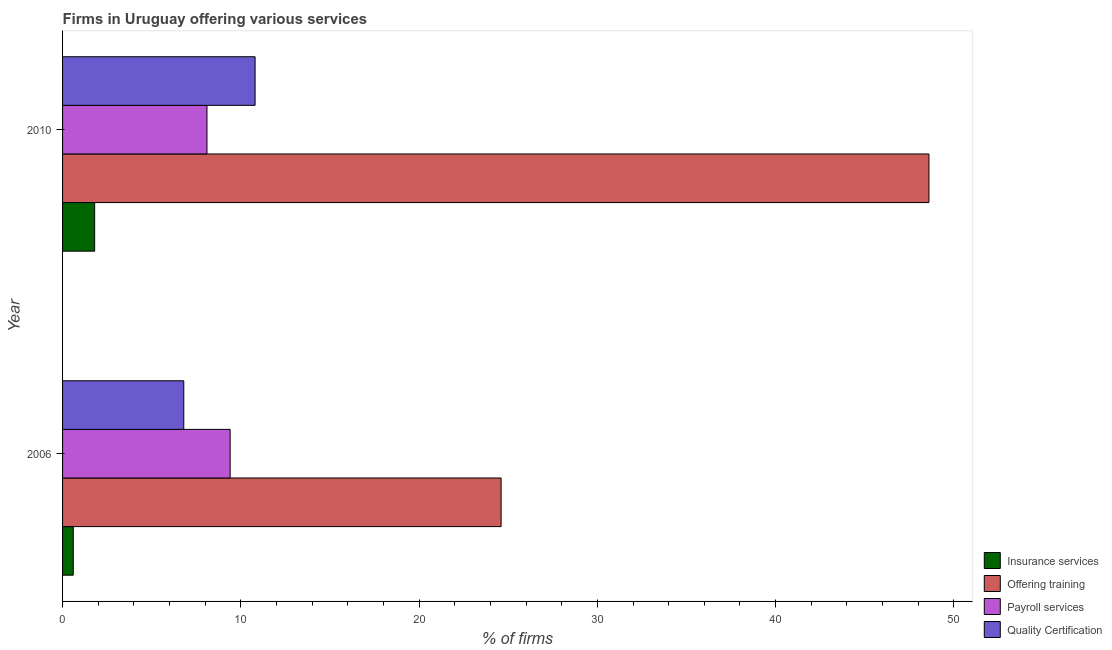How many groups of bars are there?
Make the answer very short. 2. Are the number of bars per tick equal to the number of legend labels?
Provide a succinct answer. Yes. Are the number of bars on each tick of the Y-axis equal?
Your answer should be very brief. Yes. How many bars are there on the 2nd tick from the bottom?
Your answer should be very brief. 4. What is the label of the 1st group of bars from the top?
Give a very brief answer. 2010. What is the percentage of firms offering insurance services in 2010?
Your response must be concise. 1.8. Across all years, what is the minimum percentage of firms offering training?
Ensure brevity in your answer.  24.6. What is the difference between the percentage of firms offering training in 2006 and that in 2010?
Your answer should be very brief. -24. What is the difference between the percentage of firms offering payroll services in 2010 and the percentage of firms offering quality certification in 2006?
Offer a terse response. 1.3. What is the average percentage of firms offering training per year?
Provide a succinct answer. 36.6. In the year 2006, what is the difference between the percentage of firms offering payroll services and percentage of firms offering training?
Give a very brief answer. -15.2. In how many years, is the percentage of firms offering insurance services greater than 18 %?
Your answer should be compact. 0. What is the ratio of the percentage of firms offering quality certification in 2006 to that in 2010?
Your response must be concise. 0.63. Is the percentage of firms offering payroll services in 2006 less than that in 2010?
Offer a very short reply. No. What does the 2nd bar from the top in 2006 represents?
Give a very brief answer. Payroll services. What does the 2nd bar from the bottom in 2010 represents?
Provide a succinct answer. Offering training. Is it the case that in every year, the sum of the percentage of firms offering insurance services and percentage of firms offering training is greater than the percentage of firms offering payroll services?
Offer a terse response. Yes. How many bars are there?
Provide a short and direct response. 8. Are all the bars in the graph horizontal?
Your response must be concise. Yes. What is the difference between two consecutive major ticks on the X-axis?
Your response must be concise. 10. Does the graph contain any zero values?
Make the answer very short. No. Where does the legend appear in the graph?
Give a very brief answer. Bottom right. What is the title of the graph?
Keep it short and to the point. Firms in Uruguay offering various services . What is the label or title of the X-axis?
Offer a very short reply. % of firms. What is the label or title of the Y-axis?
Offer a very short reply. Year. What is the % of firms of Insurance services in 2006?
Your answer should be compact. 0.6. What is the % of firms in Offering training in 2006?
Give a very brief answer. 24.6. What is the % of firms in Payroll services in 2006?
Your answer should be very brief. 9.4. What is the % of firms of Quality Certification in 2006?
Ensure brevity in your answer.  6.8. What is the % of firms of Insurance services in 2010?
Offer a very short reply. 1.8. What is the % of firms of Offering training in 2010?
Offer a very short reply. 48.6. What is the % of firms in Payroll services in 2010?
Provide a succinct answer. 8.1. Across all years, what is the maximum % of firms in Offering training?
Give a very brief answer. 48.6. Across all years, what is the minimum % of firms of Offering training?
Offer a very short reply. 24.6. Across all years, what is the minimum % of firms in Payroll services?
Your answer should be compact. 8.1. What is the total % of firms of Insurance services in the graph?
Your answer should be very brief. 2.4. What is the total % of firms in Offering training in the graph?
Your response must be concise. 73.2. What is the total % of firms in Payroll services in the graph?
Your answer should be very brief. 17.5. What is the difference between the % of firms of Insurance services in 2006 and the % of firms of Offering training in 2010?
Give a very brief answer. -48. What is the difference between the % of firms of Insurance services in 2006 and the % of firms of Quality Certification in 2010?
Keep it short and to the point. -10.2. What is the difference between the % of firms in Offering training in 2006 and the % of firms in Payroll services in 2010?
Your answer should be very brief. 16.5. What is the average % of firms of Offering training per year?
Make the answer very short. 36.6. What is the average % of firms of Payroll services per year?
Provide a short and direct response. 8.75. In the year 2006, what is the difference between the % of firms of Offering training and % of firms of Payroll services?
Ensure brevity in your answer.  15.2. In the year 2010, what is the difference between the % of firms in Insurance services and % of firms in Offering training?
Your response must be concise. -46.8. In the year 2010, what is the difference between the % of firms in Insurance services and % of firms in Payroll services?
Your answer should be compact. -6.3. In the year 2010, what is the difference between the % of firms of Offering training and % of firms of Payroll services?
Offer a terse response. 40.5. In the year 2010, what is the difference between the % of firms of Offering training and % of firms of Quality Certification?
Ensure brevity in your answer.  37.8. In the year 2010, what is the difference between the % of firms in Payroll services and % of firms in Quality Certification?
Your response must be concise. -2.7. What is the ratio of the % of firms of Offering training in 2006 to that in 2010?
Ensure brevity in your answer.  0.51. What is the ratio of the % of firms in Payroll services in 2006 to that in 2010?
Offer a very short reply. 1.16. What is the ratio of the % of firms of Quality Certification in 2006 to that in 2010?
Offer a very short reply. 0.63. What is the difference between the highest and the second highest % of firms of Insurance services?
Keep it short and to the point. 1.2. What is the difference between the highest and the lowest % of firms in Insurance services?
Give a very brief answer. 1.2. What is the difference between the highest and the lowest % of firms in Offering training?
Provide a short and direct response. 24. What is the difference between the highest and the lowest % of firms in Payroll services?
Your answer should be very brief. 1.3. What is the difference between the highest and the lowest % of firms in Quality Certification?
Provide a short and direct response. 4. 